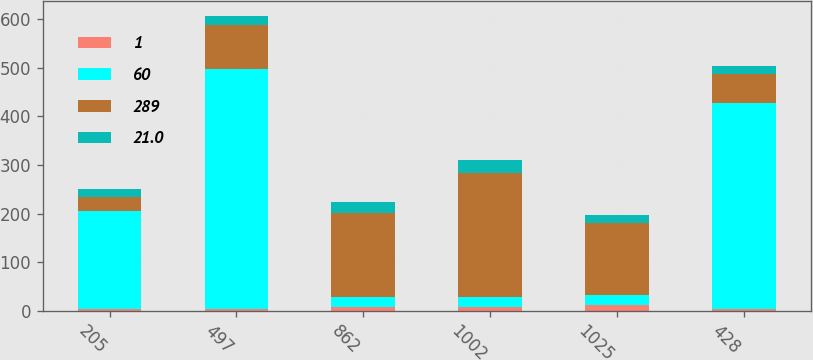<chart> <loc_0><loc_0><loc_500><loc_500><stacked_bar_chart><ecel><fcel>205<fcel>497<fcel>862<fcel>1002<fcel>1025<fcel>428<nl><fcel>1<fcel>3<fcel>4<fcel>7<fcel>7<fcel>12<fcel>4<nl><fcel>60<fcel>202<fcel>493<fcel>21<fcel>21<fcel>21<fcel>424<nl><fcel>289<fcel>30<fcel>90<fcel>174<fcel>255<fcel>148<fcel>60<nl><fcel>21<fcel>16.1<fcel>18.9<fcel>21<fcel>26.1<fcel>15.6<fcel>15<nl></chart> 